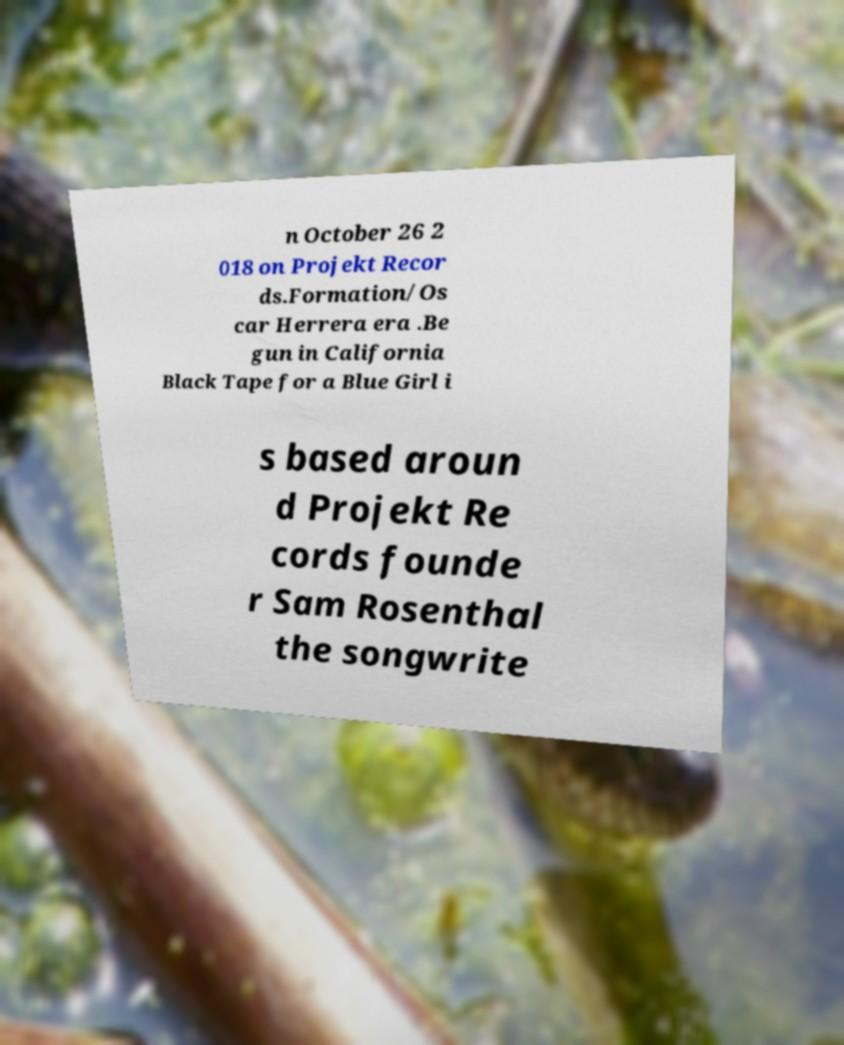Could you assist in decoding the text presented in this image and type it out clearly? n October 26 2 018 on Projekt Recor ds.Formation/Os car Herrera era .Be gun in California Black Tape for a Blue Girl i s based aroun d Projekt Re cords founde r Sam Rosenthal the songwrite 